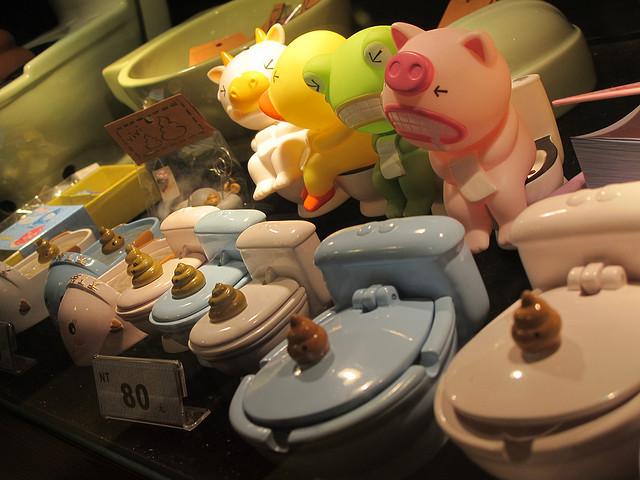Is that poop?
Keep it brief. No. What are the figures in front?
Quick response, please. Toilets. Which toy represents an animal that quacks?
Keep it brief. Duck. Would this be a good present for a young child?
Be succinct. No. 